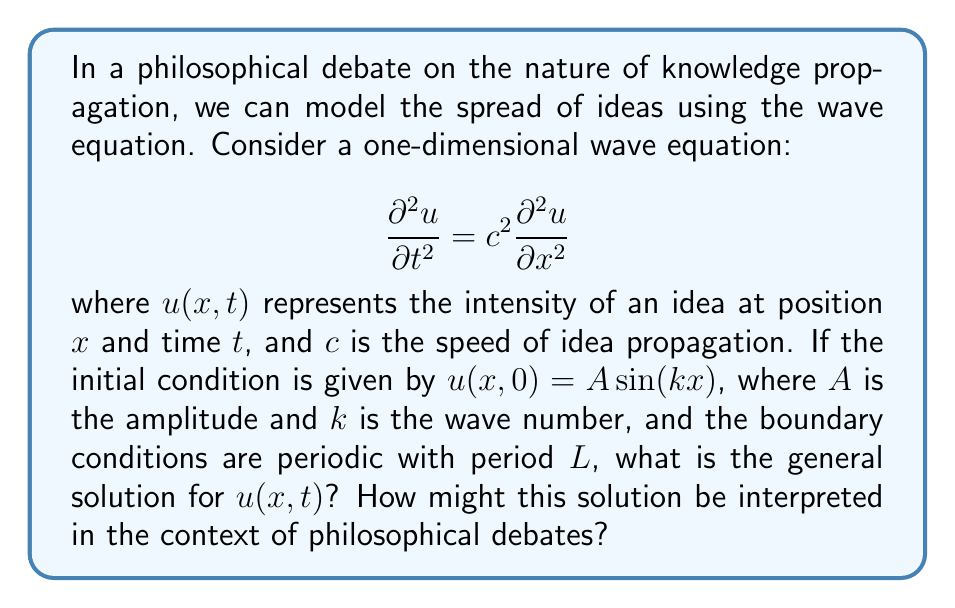Could you help me with this problem? To solve this problem, we'll follow these steps:

1) The general solution for the wave equation with periodic boundary conditions is of the form:

   $$u(x,t) = f(x-ct) + g(x+ct)$$

   where $f$ and $g$ are arbitrary functions.

2) Given the initial condition $u(x,0) = A \sin(kx)$, we can write:

   $$f(x) + g(x) = A \sin(kx)$$

3) To satisfy the periodic boundary conditions, we must have $k = \frac{2\pi n}{L}$, where $n$ is an integer.

4) The solution that satisfies both the initial condition and the wave equation is:

   $$u(x,t) = \frac{A}{2}[\sin(k(x-ct)) + \sin(k(x+ct))]$$

5) Using the trigonometric identity for the sum of sines, we can rewrite this as:

   $$u(x,t) = A \sin(kx) \cos(kct)$$

This solution represents a standing wave, which can be interpreted in the context of philosophical debates as follows:

- The sine term $\sin(kx)$ represents the spatial distribution of the idea's intensity.
- The cosine term $\cos(kct)$ represents the temporal oscillation of the idea's intensity.
- The amplitude $A$ represents the maximum intensity of the idea.
- The wave number $k$ (or wavelength $\lambda = \frac{2\pi}{k}$) represents the spatial frequency of idea variation.
- The speed $c$ represents how quickly the idea propagates through the philosophical community.

This standing wave solution suggests that in a philosophical debate, ideas may not simply propagate linearly, but instead form patterns of reinforcement and interference. Some locations (represented by $x$) may consistently be nodes (points of no intensity) or antinodes (points of maximum intensity) for certain ideas, while the overall intensity of the debate oscillates over time.
Answer: The general solution is:

$$u(x,t) = A \sin(kx) \cos(kct)$$

where $k = \frac{2\pi n}{L}$, $n$ is an integer, $A$ is the amplitude, $c$ is the speed of idea propagation, $x$ is the position, and $t$ is the time. 